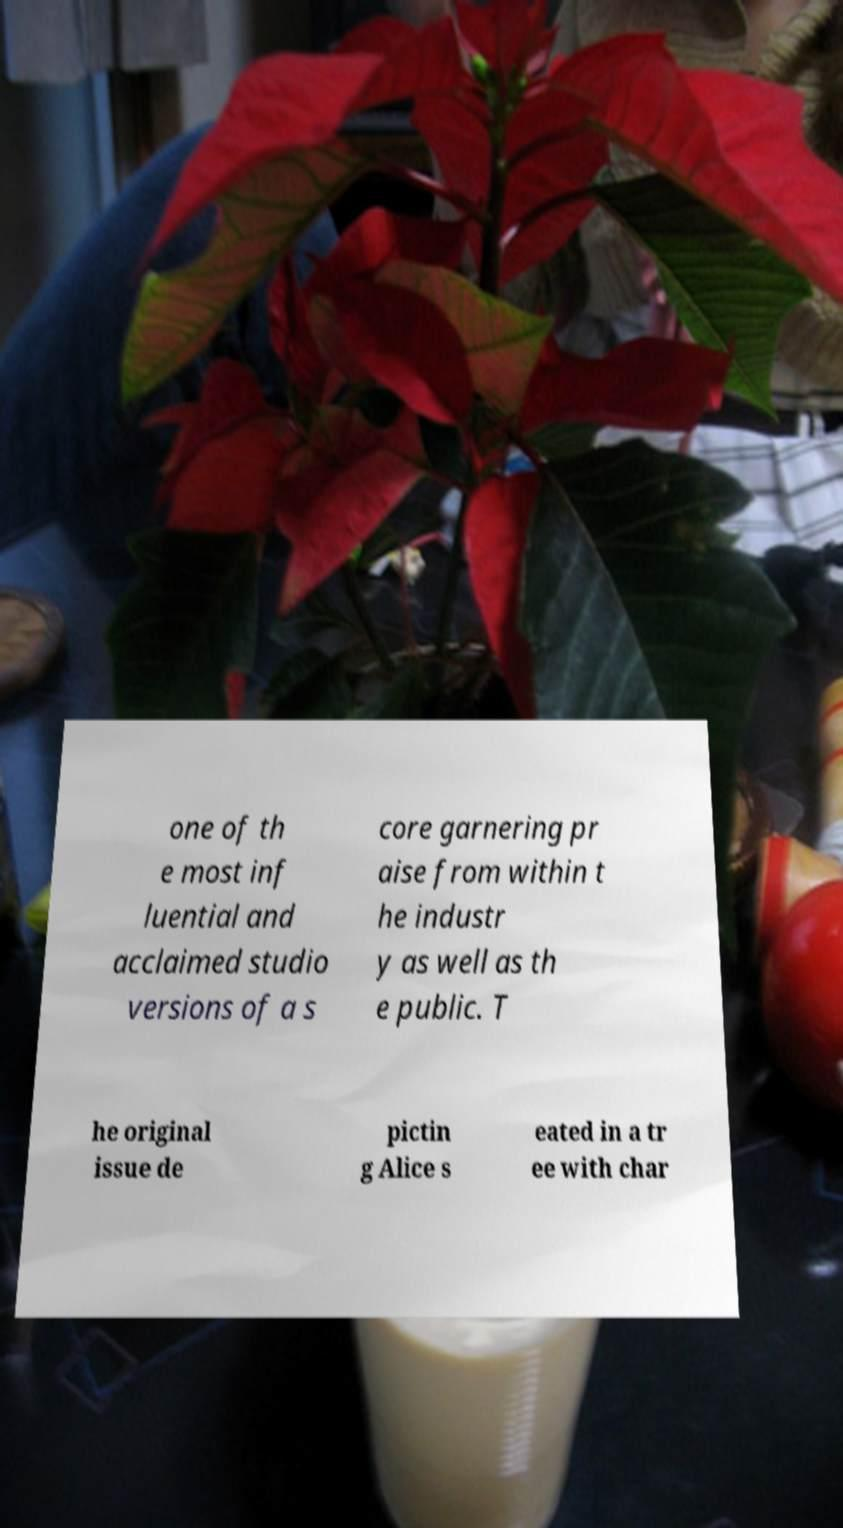Can you accurately transcribe the text from the provided image for me? one of th e most inf luential and acclaimed studio versions of a s core garnering pr aise from within t he industr y as well as th e public. T he original issue de pictin g Alice s eated in a tr ee with char 